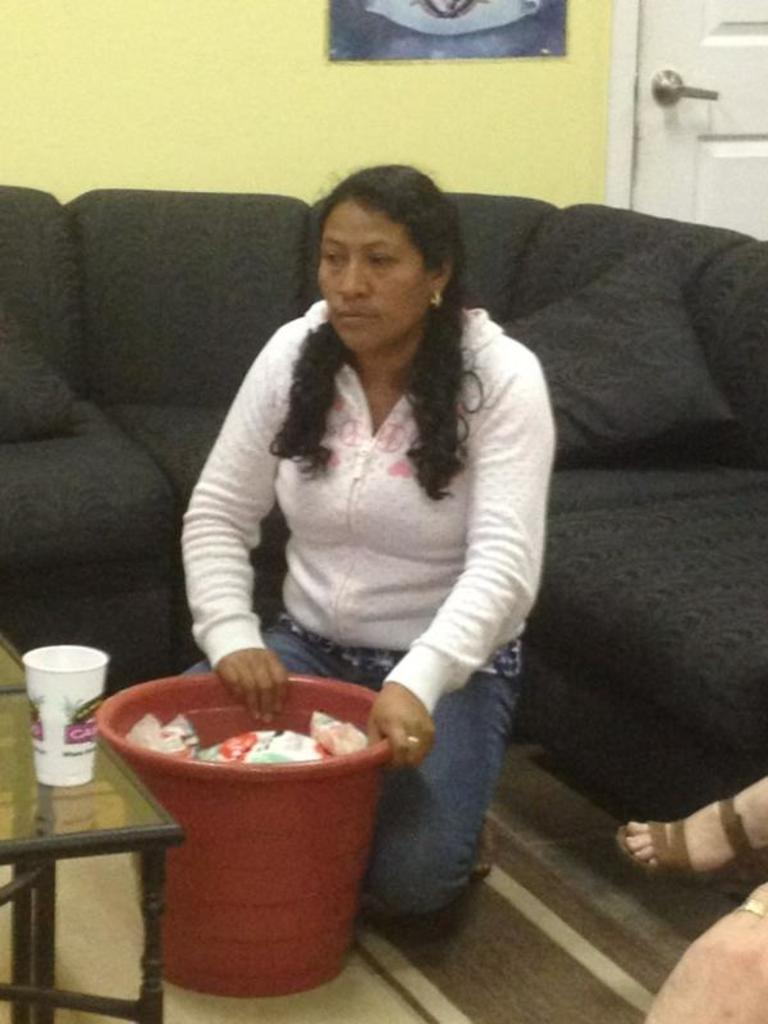Who is present in the image? There is a woman in the image. What is the woman doing in the image? The woman is sitting. What is in front of the woman in the image? There is a bucket of packets in front of the woman. What can be seen in the background of the image? There is a sofa in the background of the image. What type of curtain can be seen in the image? There is no curtain present in the image. What details about the woman's clothing can be observed in the image? The provided facts do not mention any details about the woman's clothing. 